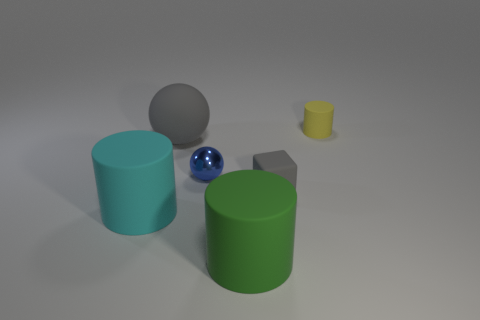Add 2 small purple cylinders. How many objects exist? 8 Subtract all balls. How many objects are left? 4 Add 3 big green rubber things. How many big green rubber things are left? 4 Add 5 gray rubber things. How many gray rubber things exist? 7 Subtract 0 brown cylinders. How many objects are left? 6 Subtract all tiny yellow cylinders. Subtract all tiny blue shiny spheres. How many objects are left? 4 